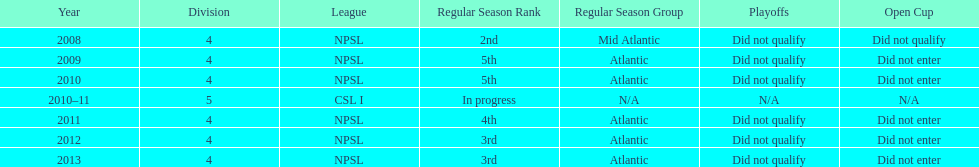What is the only year that is n/a? 2010-11. 